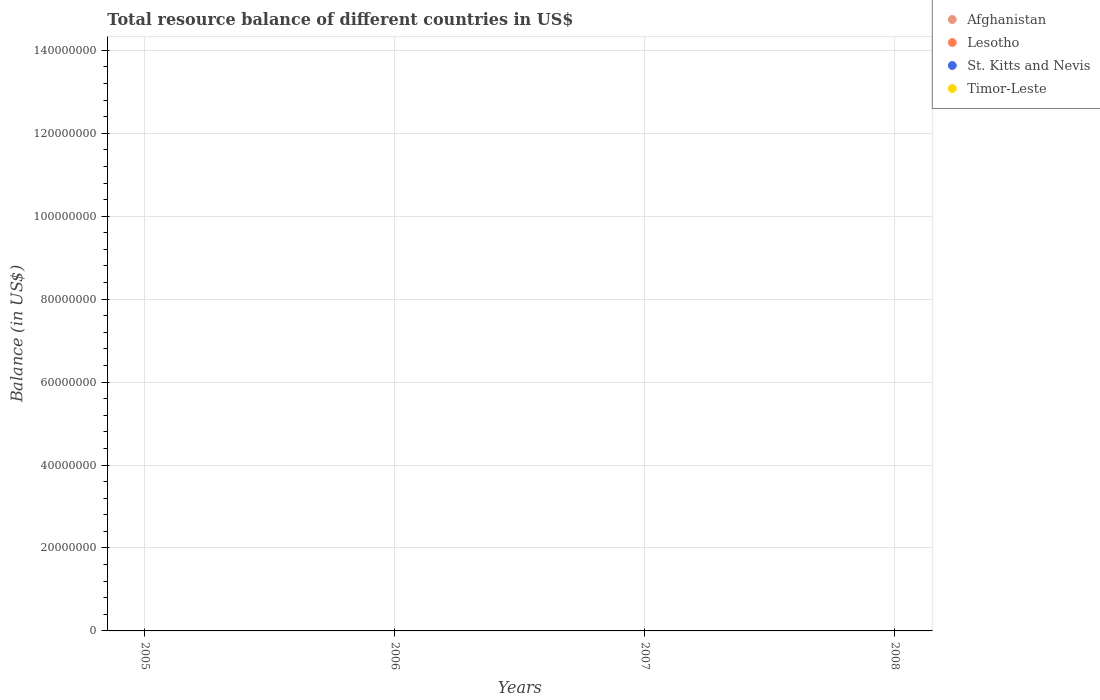How many different coloured dotlines are there?
Provide a succinct answer. 0. What is the total resource balance in Afghanistan in 2005?
Your answer should be very brief. 0. What is the average total resource balance in Timor-Leste per year?
Give a very brief answer. 0. In how many years, is the total resource balance in Lesotho greater than the average total resource balance in Lesotho taken over all years?
Your answer should be very brief. 0. Is it the case that in every year, the sum of the total resource balance in Lesotho and total resource balance in Afghanistan  is greater than the sum of total resource balance in Timor-Leste and total resource balance in St. Kitts and Nevis?
Your answer should be compact. No. Is the total resource balance in Lesotho strictly greater than the total resource balance in Afghanistan over the years?
Provide a succinct answer. Yes. Is the total resource balance in Afghanistan strictly less than the total resource balance in Timor-Leste over the years?
Your answer should be compact. Yes. How many dotlines are there?
Make the answer very short. 0. How many years are there in the graph?
Provide a succinct answer. 4. What is the difference between two consecutive major ticks on the Y-axis?
Keep it short and to the point. 2.00e+07. How are the legend labels stacked?
Provide a succinct answer. Vertical. What is the title of the graph?
Ensure brevity in your answer.  Total resource balance of different countries in US$. Does "Brazil" appear as one of the legend labels in the graph?
Your answer should be compact. No. What is the label or title of the X-axis?
Ensure brevity in your answer.  Years. What is the label or title of the Y-axis?
Provide a succinct answer. Balance (in US$). What is the Balance (in US$) in Afghanistan in 2005?
Your response must be concise. 0. What is the Balance (in US$) of Afghanistan in 2006?
Give a very brief answer. 0. What is the Balance (in US$) of Afghanistan in 2007?
Your answer should be very brief. 0. What is the Balance (in US$) of Timor-Leste in 2007?
Offer a terse response. 0. What is the Balance (in US$) in Lesotho in 2008?
Ensure brevity in your answer.  0. What is the Balance (in US$) of St. Kitts and Nevis in 2008?
Your answer should be very brief. 0. What is the Balance (in US$) in Timor-Leste in 2008?
Keep it short and to the point. 0. What is the total Balance (in US$) of Lesotho in the graph?
Your response must be concise. 0. What is the total Balance (in US$) in St. Kitts and Nevis in the graph?
Provide a succinct answer. 0. What is the average Balance (in US$) in Lesotho per year?
Provide a succinct answer. 0. What is the average Balance (in US$) of St. Kitts and Nevis per year?
Keep it short and to the point. 0. What is the average Balance (in US$) of Timor-Leste per year?
Your response must be concise. 0. 